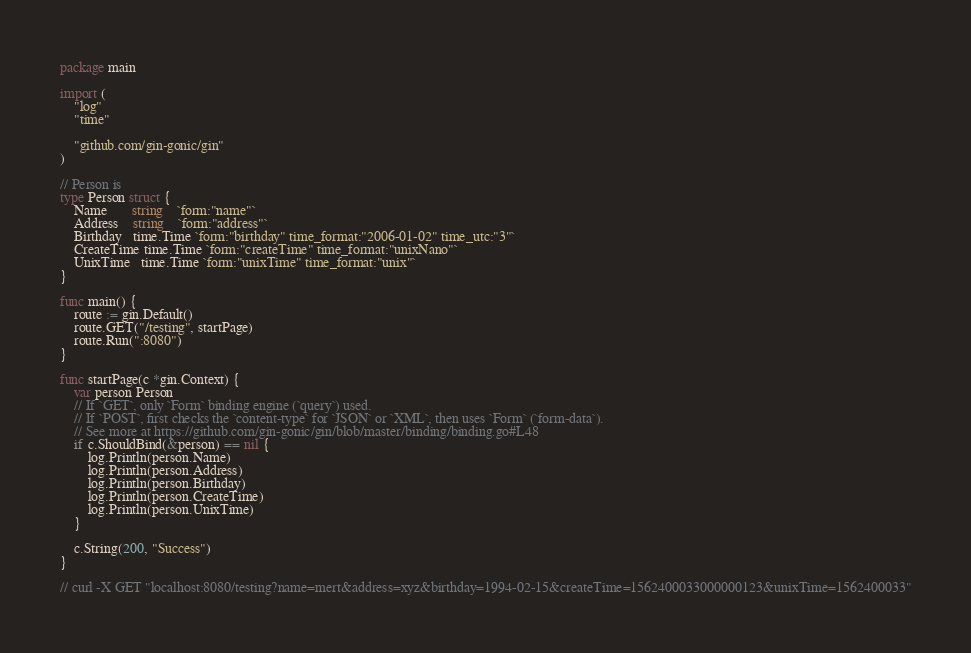Convert code to text. <code><loc_0><loc_0><loc_500><loc_500><_Go_>package main

import (
	"log"
	"time"

	"github.com/gin-gonic/gin"
)

// Person is
type Person struct {
	Name       string    `form:"name"`
	Address    string    `form:"address"`
	Birthday   time.Time `form:"birthday" time_format:"2006-01-02" time_utc:"3"`
	CreateTime time.Time `form:"createTime" time_format:"unixNano"`
	UnixTime   time.Time `form:"unixTime" time_format:"unix"`
}

func main() {
	route := gin.Default()
	route.GET("/testing", startPage)
	route.Run(":8080")
}

func startPage(c *gin.Context) {
	var person Person
	// If `GET`, only `Form` binding engine (`query`) used.
	// If `POST`, first checks the `content-type` for `JSON` or `XML`, then uses `Form` (`form-data`).
	// See more at https://github.com/gin-gonic/gin/blob/master/binding/binding.go#L48
	if c.ShouldBind(&person) == nil {
		log.Println(person.Name)
		log.Println(person.Address)
		log.Println(person.Birthday)
		log.Println(person.CreateTime)
		log.Println(person.UnixTime)
	}

	c.String(200, "Success")
}

// curl -X GET "localhost:8080/testing?name=mert&address=xyz&birthday=1994-02-15&createTime=1562400033000000123&unixTime=1562400033"
</code> 